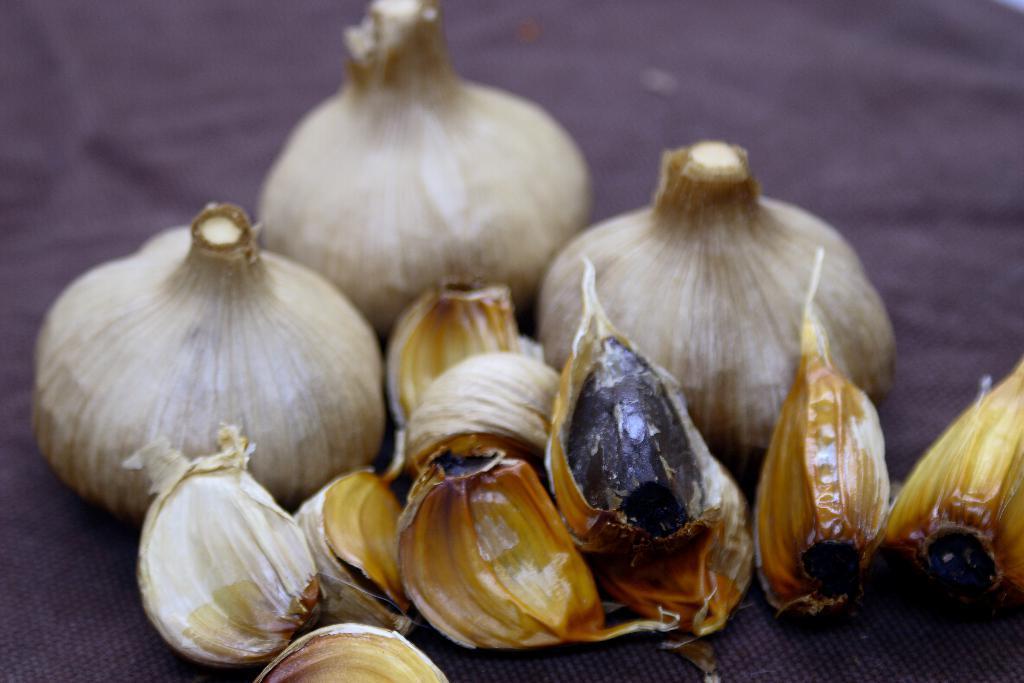In one or two sentences, can you explain what this image depicts? In the image there are Garlic and three garlic are untouched and beside them there are few garlic cloves. 